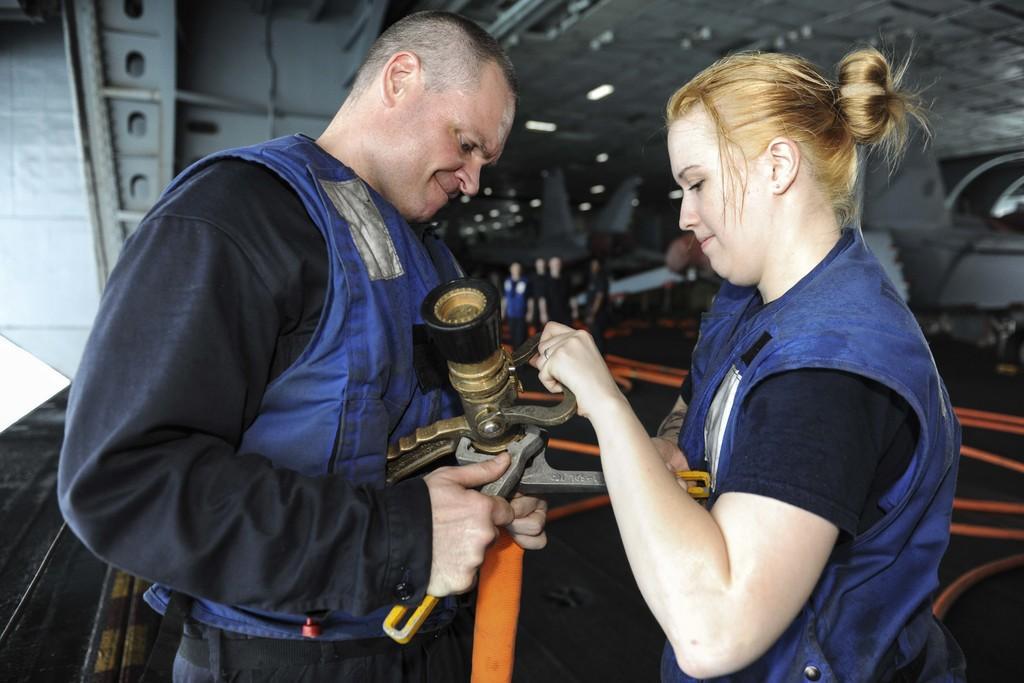In one or two sentences, can you explain what this image depicts? In this image there are two persons standing and holding an object , and at the background there are group of people standing, lights. 